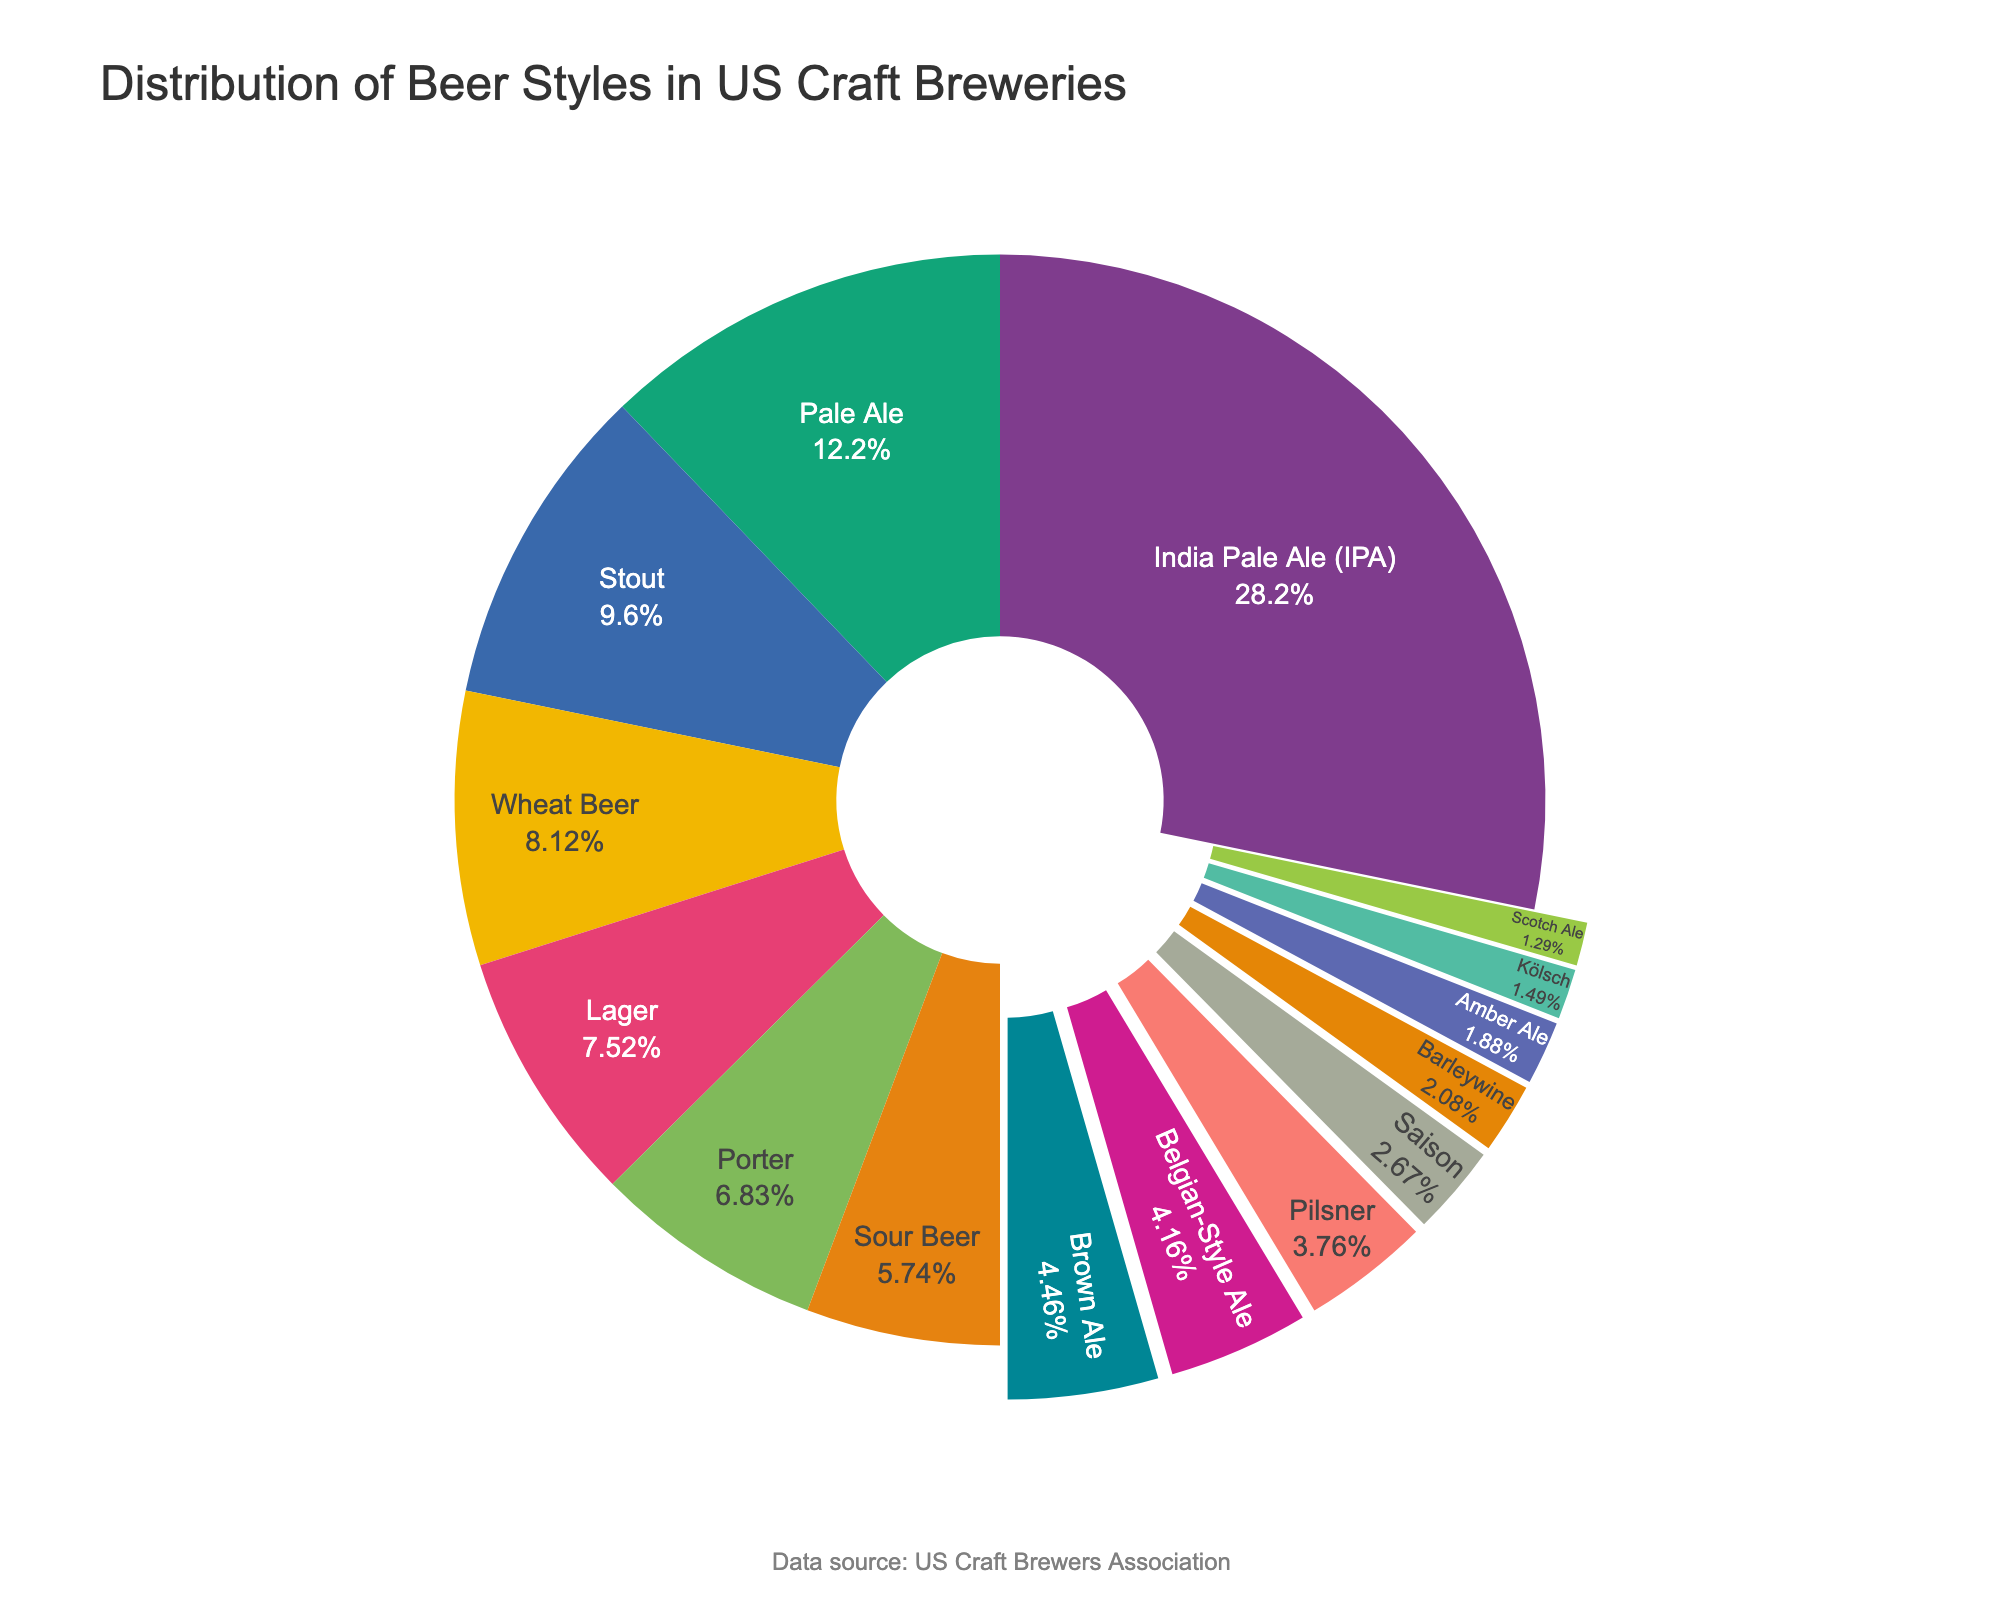What is the most produced beer style by craft breweries in the US? The largest slice in the pie chart represents 28.5% of the total, indicating the most produced beer style.
Answer: India Pale Ale (IPA) Which beer style has a higher percentage, Stout or Lager? By visually comparing the slices, Stout is 9.7% and Lager is 7.6%. Stout has a higher percentage.
Answer: Stout What is the combined percentage of Pale Ale and Stout? Add the percentages of Pale Ale (12.3%) and Stout (9.7%) to get the total.
Answer: 22% Which beer styles have a smaller percentage than Porter? Identify the beer styles with slices smaller than Porter (6.9%); they include Sour Beer, Brown Ale, Belgian-Style Ale, Pilsner, Saison, Barleywine, Amber Ale, Kölsch, and Scotch Ale.
Answer: Nine beer styles How many beer styles make up more than 10% of the distribution? Count the slices where the percentage is greater than 10%. Only India Pale Ale (28.5%) and Pale Ale (12.3%) meet this criterion.
Answer: Two beer styles Which beer style has a slice pulled out of the pie chart but is not adjacent to the hole? The pie chart has some slices pulled out if they are under 5%, here Scotch Ale (1.3%) fits this criterion.
Answer: Scotch Ale What is the total percentage of beer styles under 5% each? Add the percentages of Sour Beer (5.8%), Brown Ale (4.5%), Belgian-Style Ale (4.2%), Pilsner (3.8%), Saison (2.7%), Barleywine (2.1%), Amber Ale (1.9%), Kölsch (1.5%), and Scotch Ale (1.3%): 5.8 + 4.5 + 4.2 + 3.8 + 2.7 + 2.1 + 1.9 + 1.5 + 1.3 = 27.8.
Answer: 27.8% Is the percentage of Saison beer closer to that of Porter or that of Barleywine? Compare the percentages of Saison (2.7%), Porter (6.9%), and Barleywine (2.1%). The difference between Saison and Porter is 4.2%, and the difference between Saison and Barleywine is 0.6%. Saison is closer to Barleywine.
Answer: Barleywine What is the median percentage of the beer styles? Arrange the percentages in ascending order: 1.3, 1.5, 1.9, 2.1, 2.7, 3.8, 4.2, 4.5, 5.8, 6.9, 7.6, 8.2, 9.7, 12.3, 28.5. The middle value (median) is the 8th value in the sorted list.
Answer: 4.5% What percentage of beer styles fall within 5% to 10%? Identify beer styles whose percentage is between 5% and 10%: Stout (9.7%), Wheat Beer (8.2%), and Lager (7.6%). Count these styles.
Answer: Three beer styles 